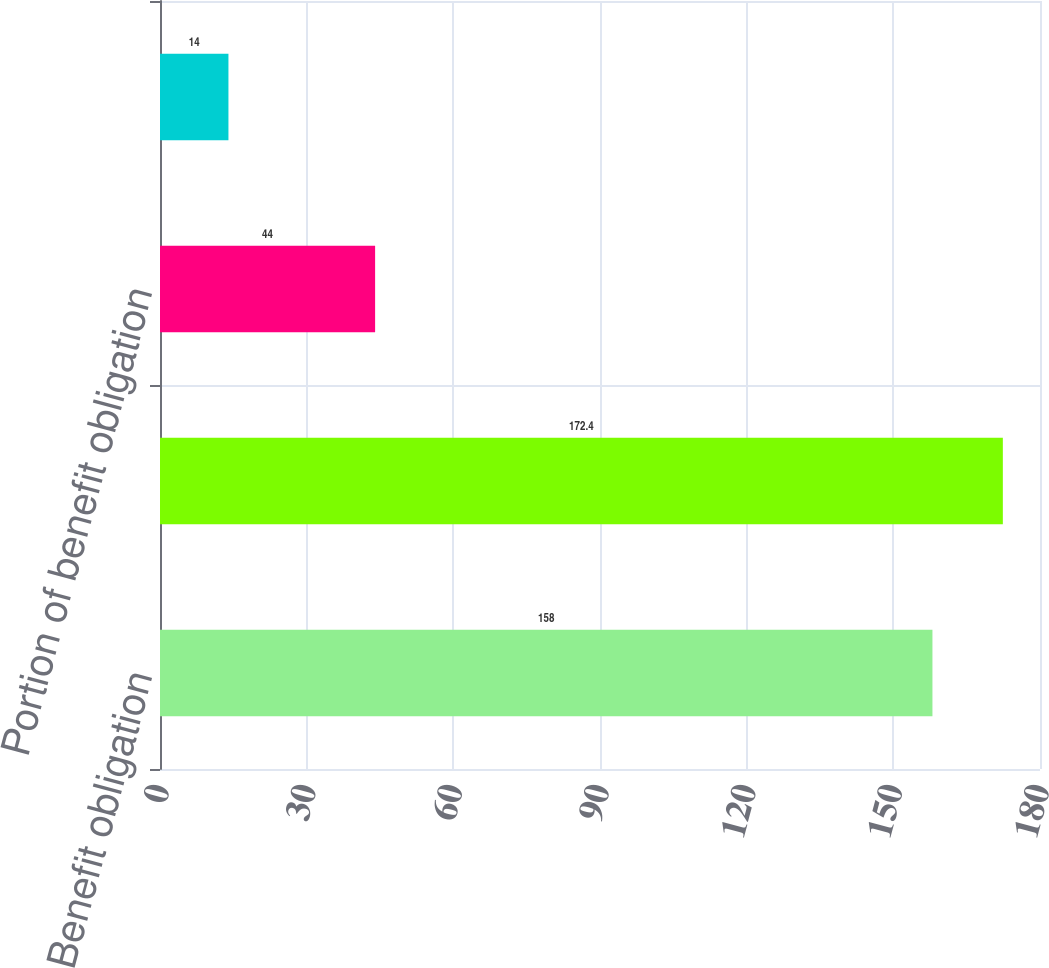Convert chart. <chart><loc_0><loc_0><loc_500><loc_500><bar_chart><fcel>Benefit obligation<fcel>Plan funded status and<fcel>Portion of benefit obligation<fcel>Benefits expense<nl><fcel>158<fcel>172.4<fcel>44<fcel>14<nl></chart> 